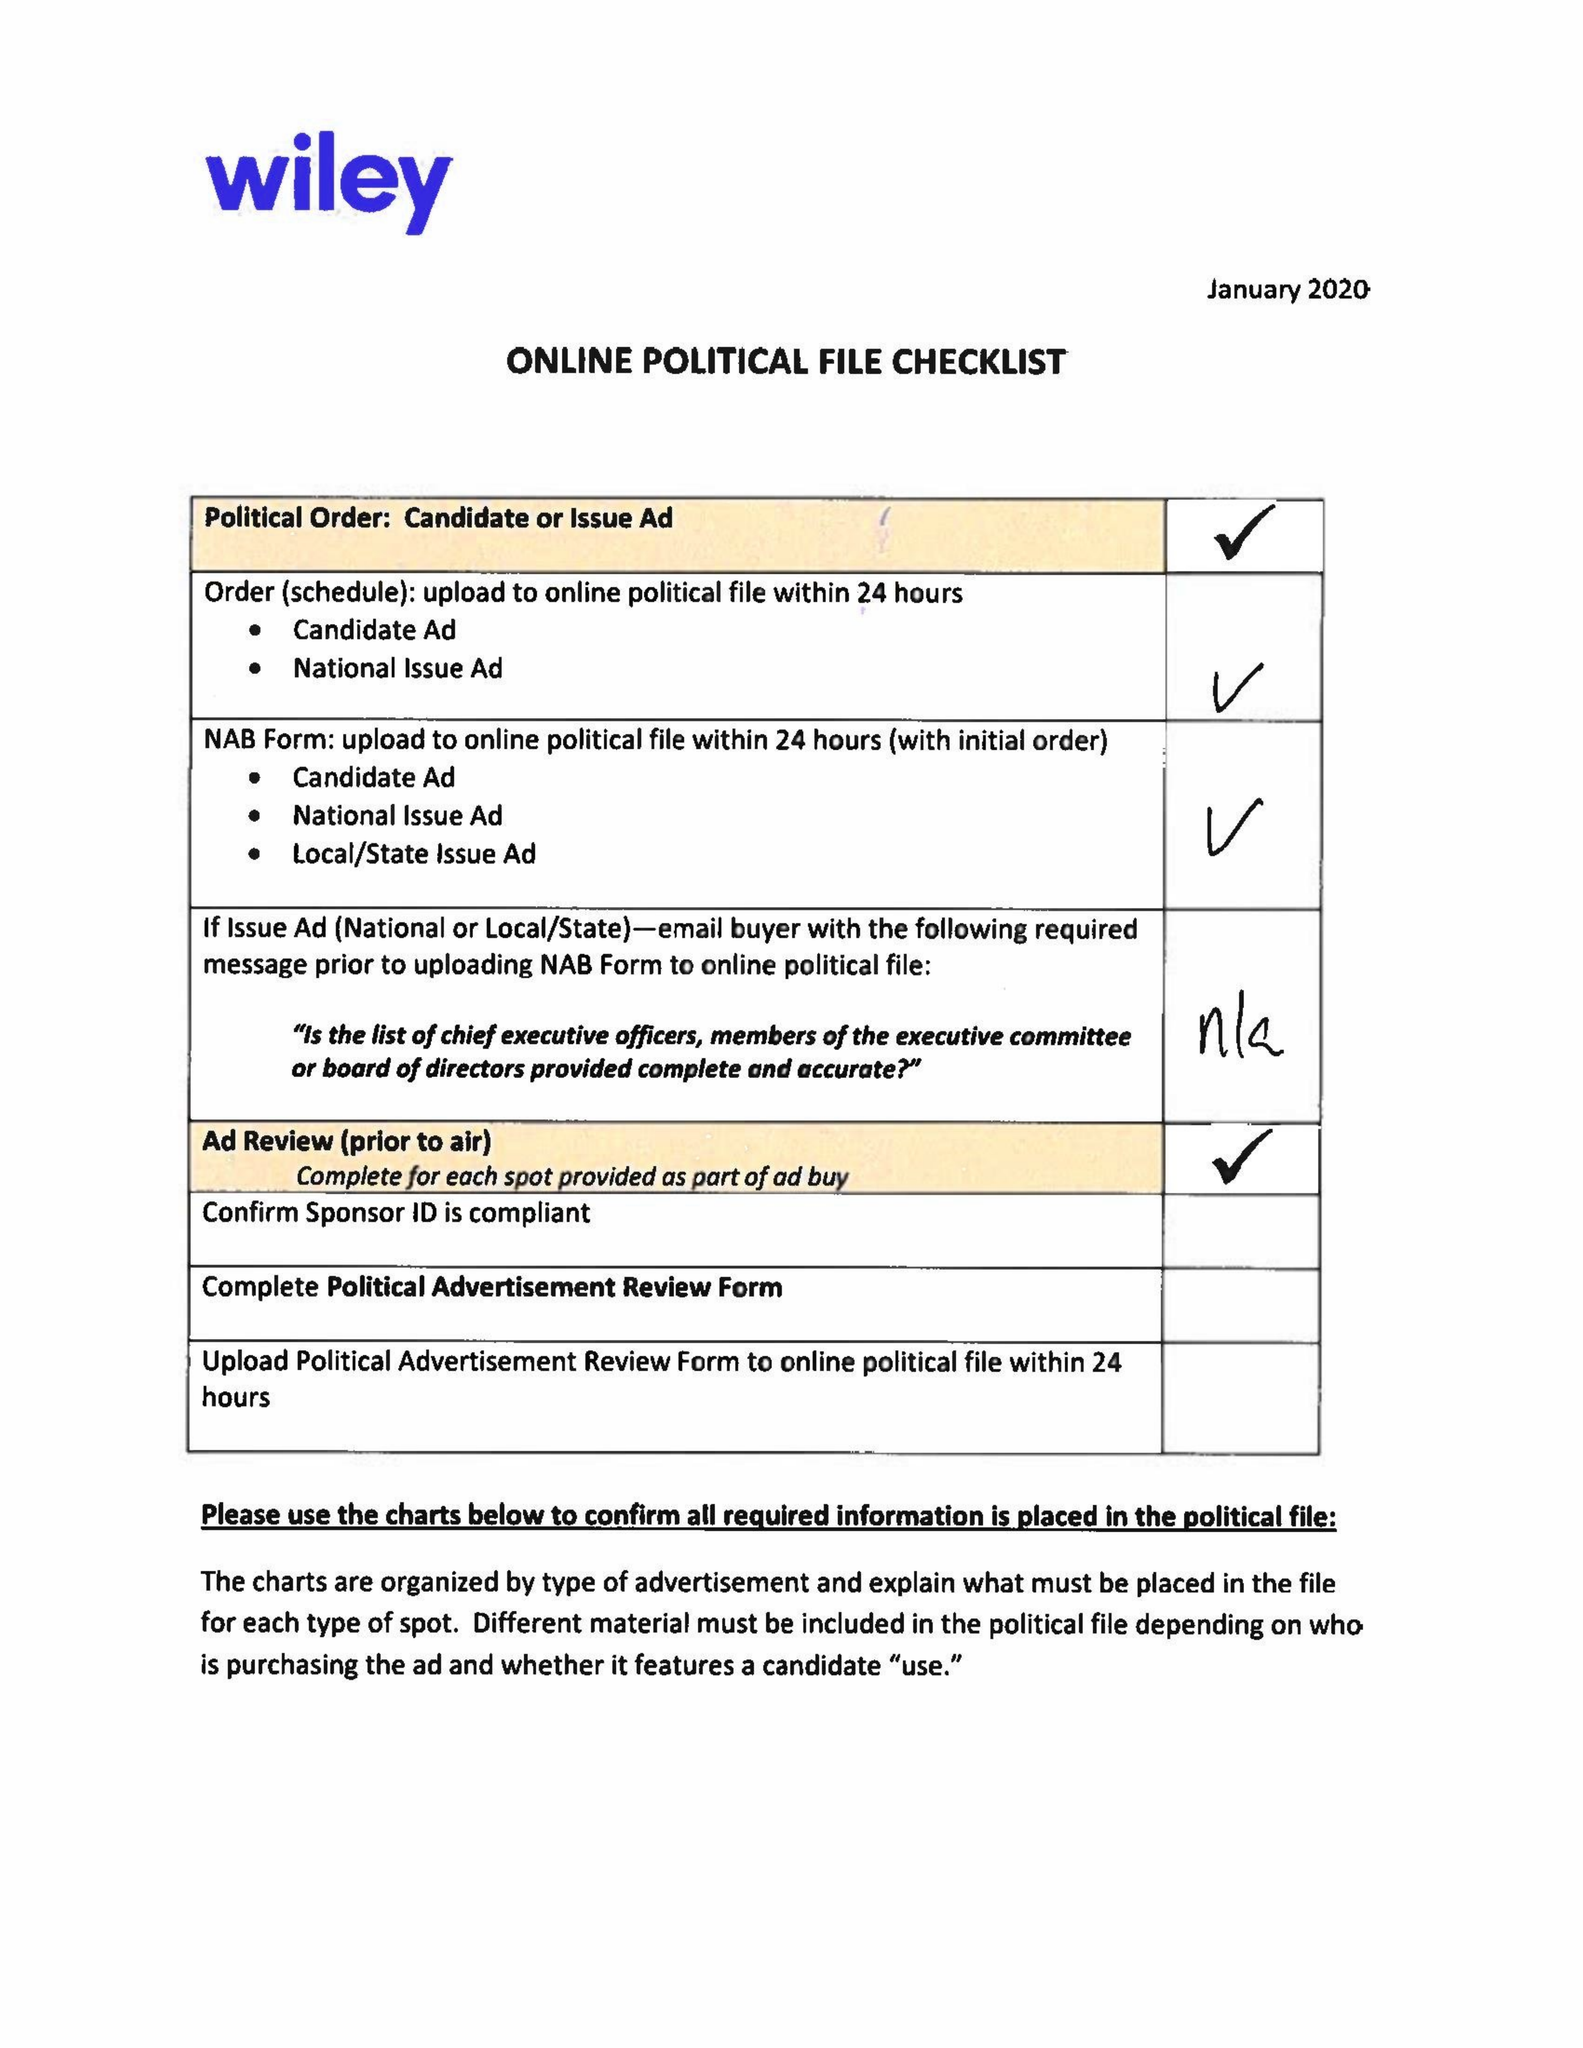What is the value for the flight_from?
Answer the question using a single word or phrase. 02/12/20 